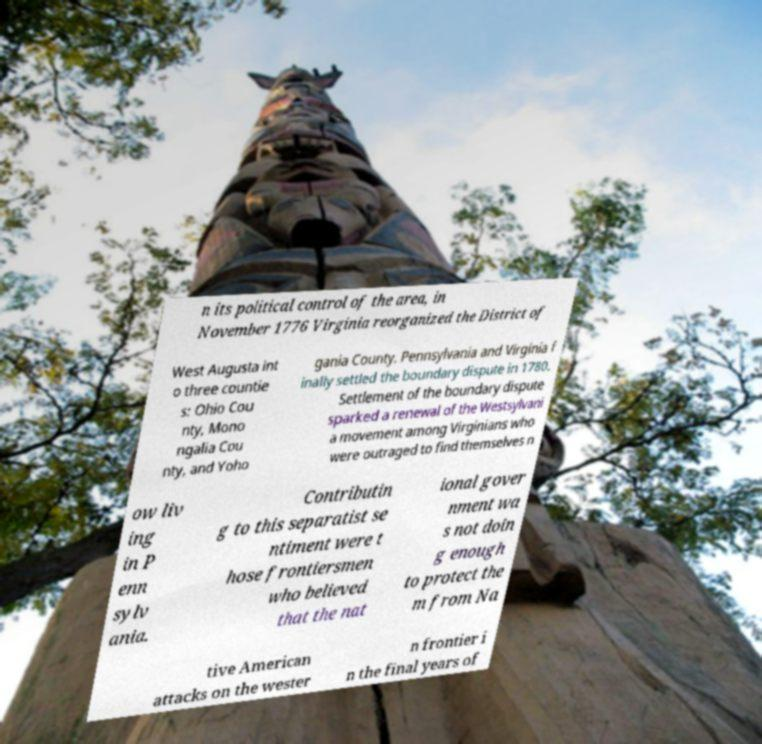Please read and relay the text visible in this image. What does it say? n its political control of the area, in November 1776 Virginia reorganized the District of West Augusta int o three countie s: Ohio Cou nty, Mono ngalia Cou nty, and Yoho gania County. Pennsylvania and Virginia f inally settled the boundary dispute in 1780. Settlement of the boundary dispute sparked a renewal of the Westsylvani a movement among Virginians who were outraged to find themselves n ow liv ing in P enn sylv ania. Contributin g to this separatist se ntiment were t hose frontiersmen who believed that the nat ional gover nment wa s not doin g enough to protect the m from Na tive American attacks on the wester n frontier i n the final years of 